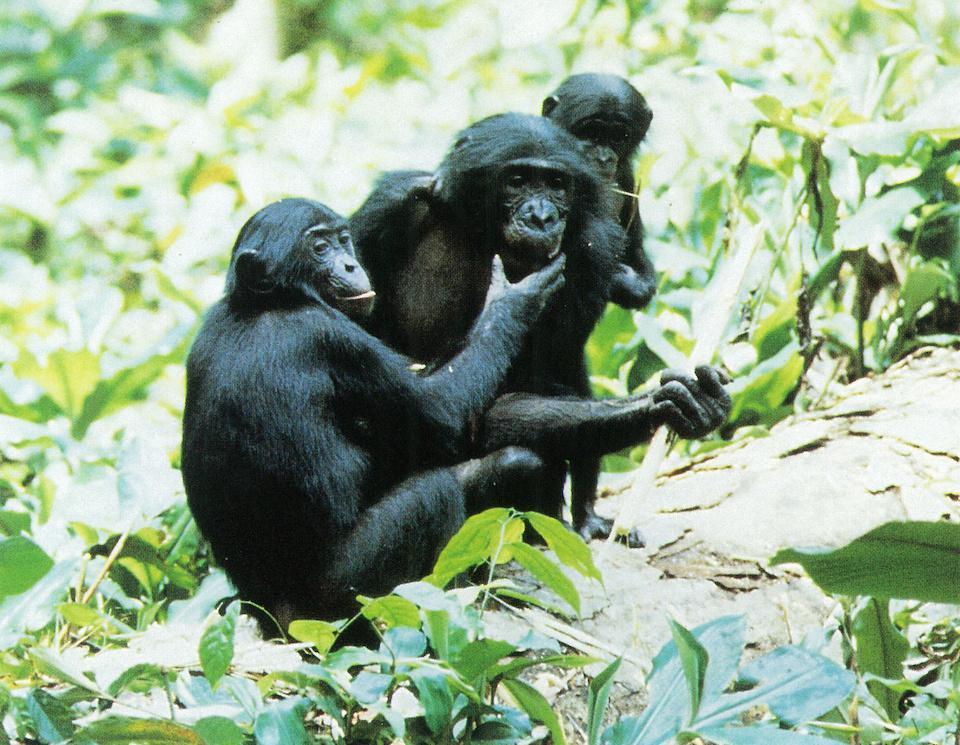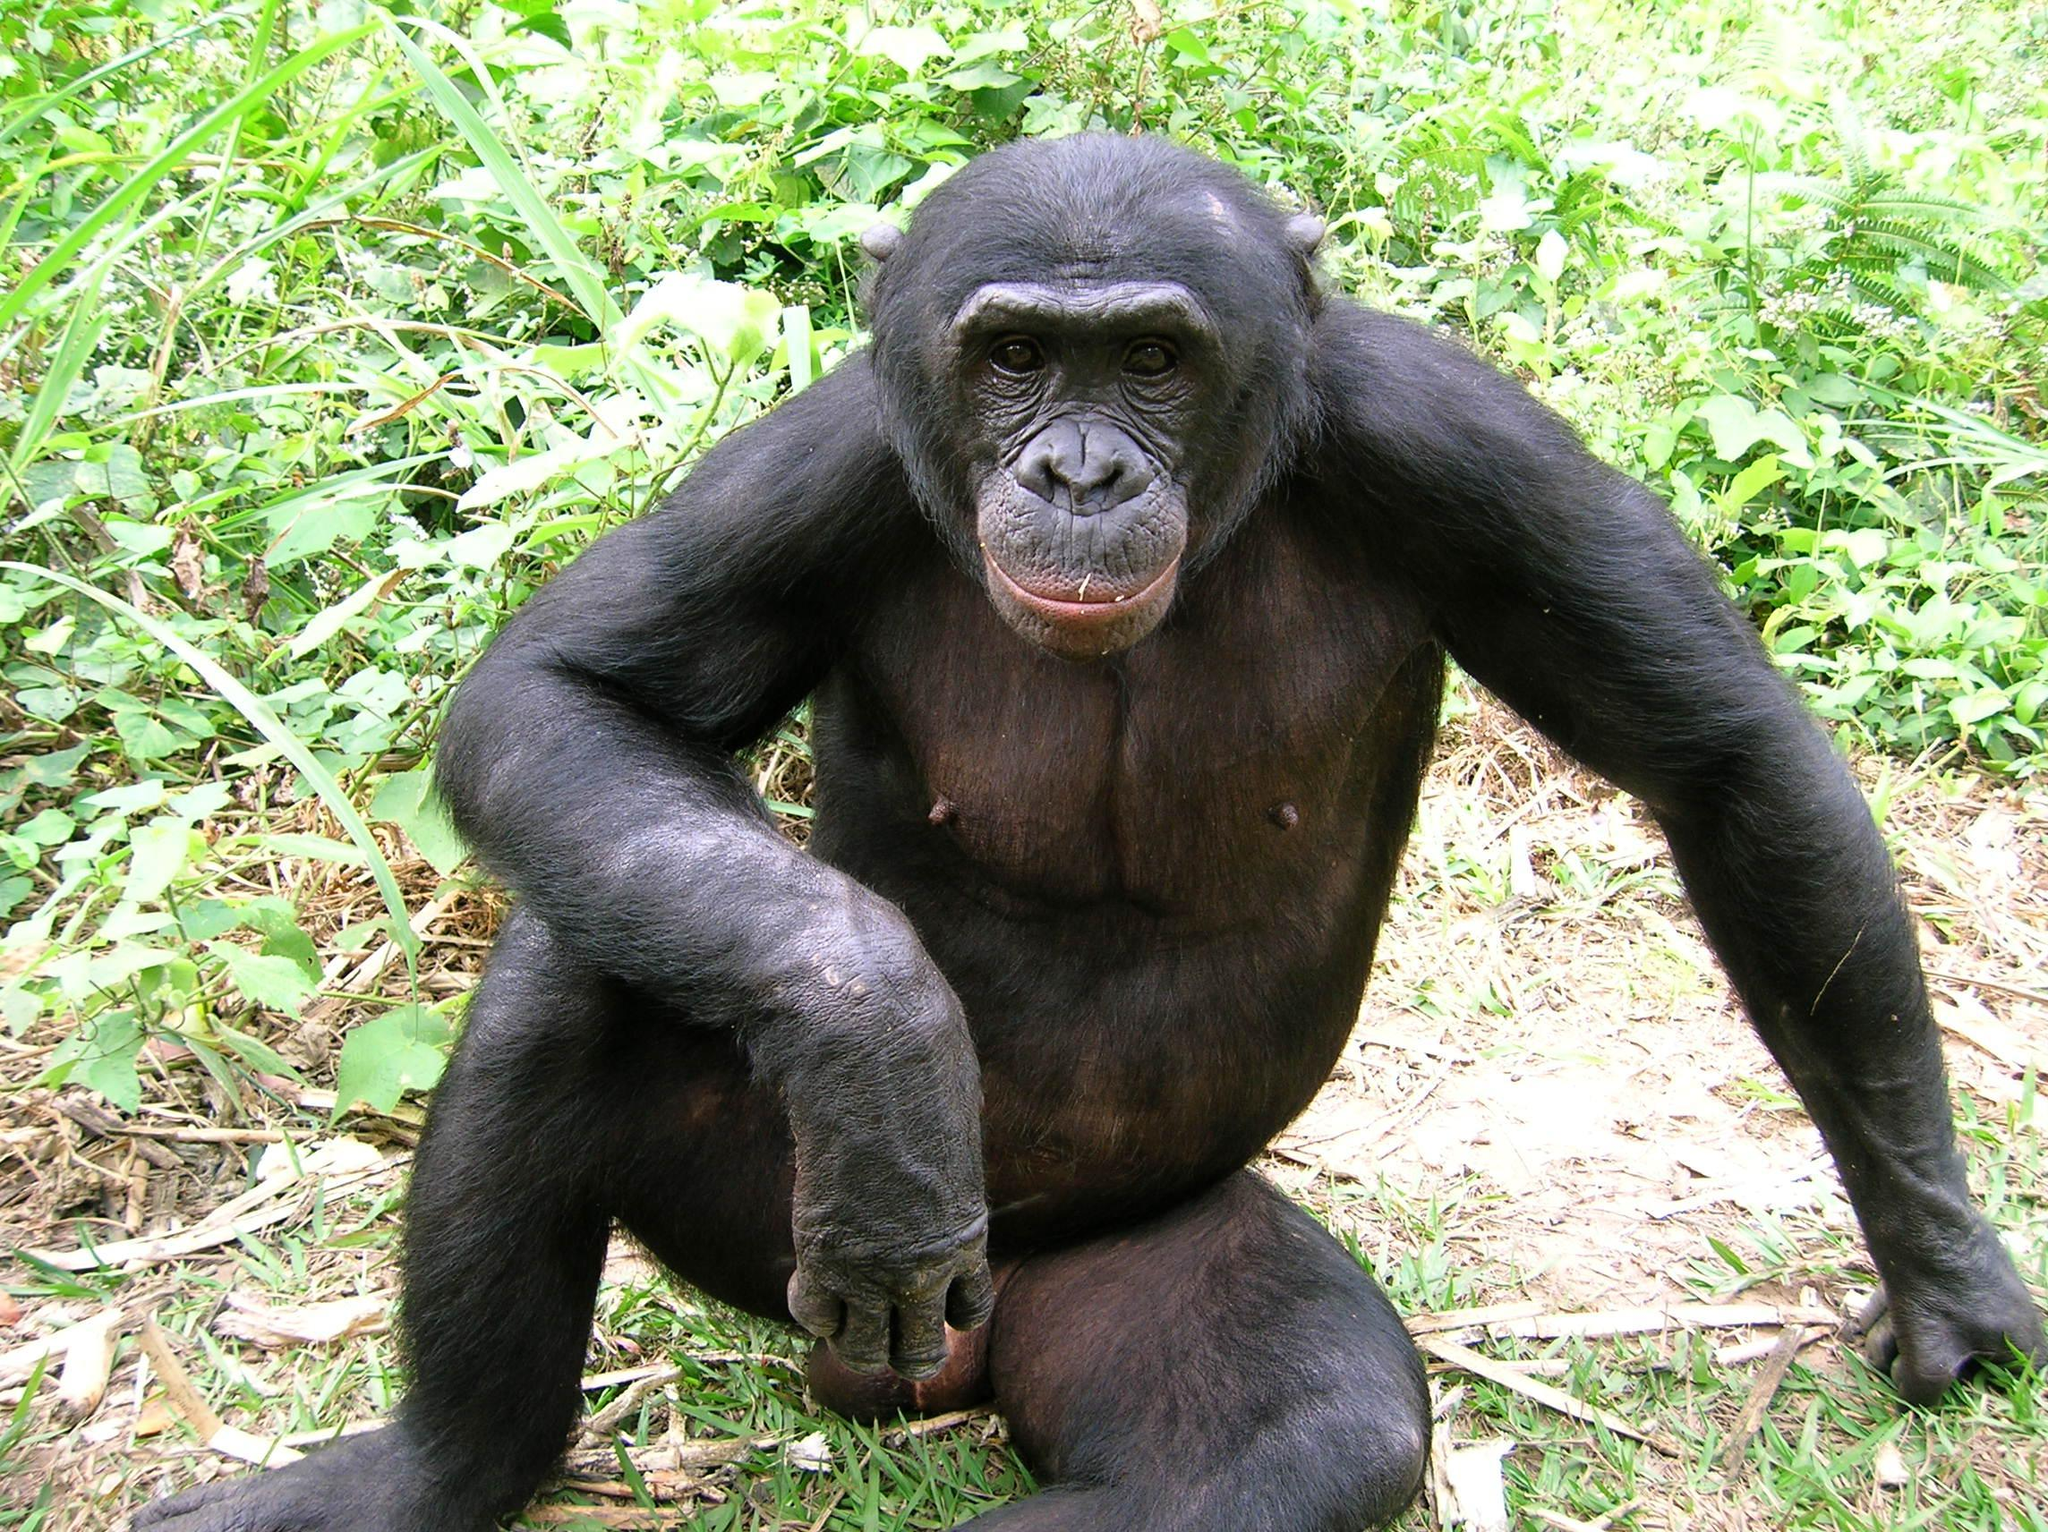The first image is the image on the left, the second image is the image on the right. Examine the images to the left and right. Is the description "The left image contains at least three chimpanzees." accurate? Answer yes or no. Yes. 